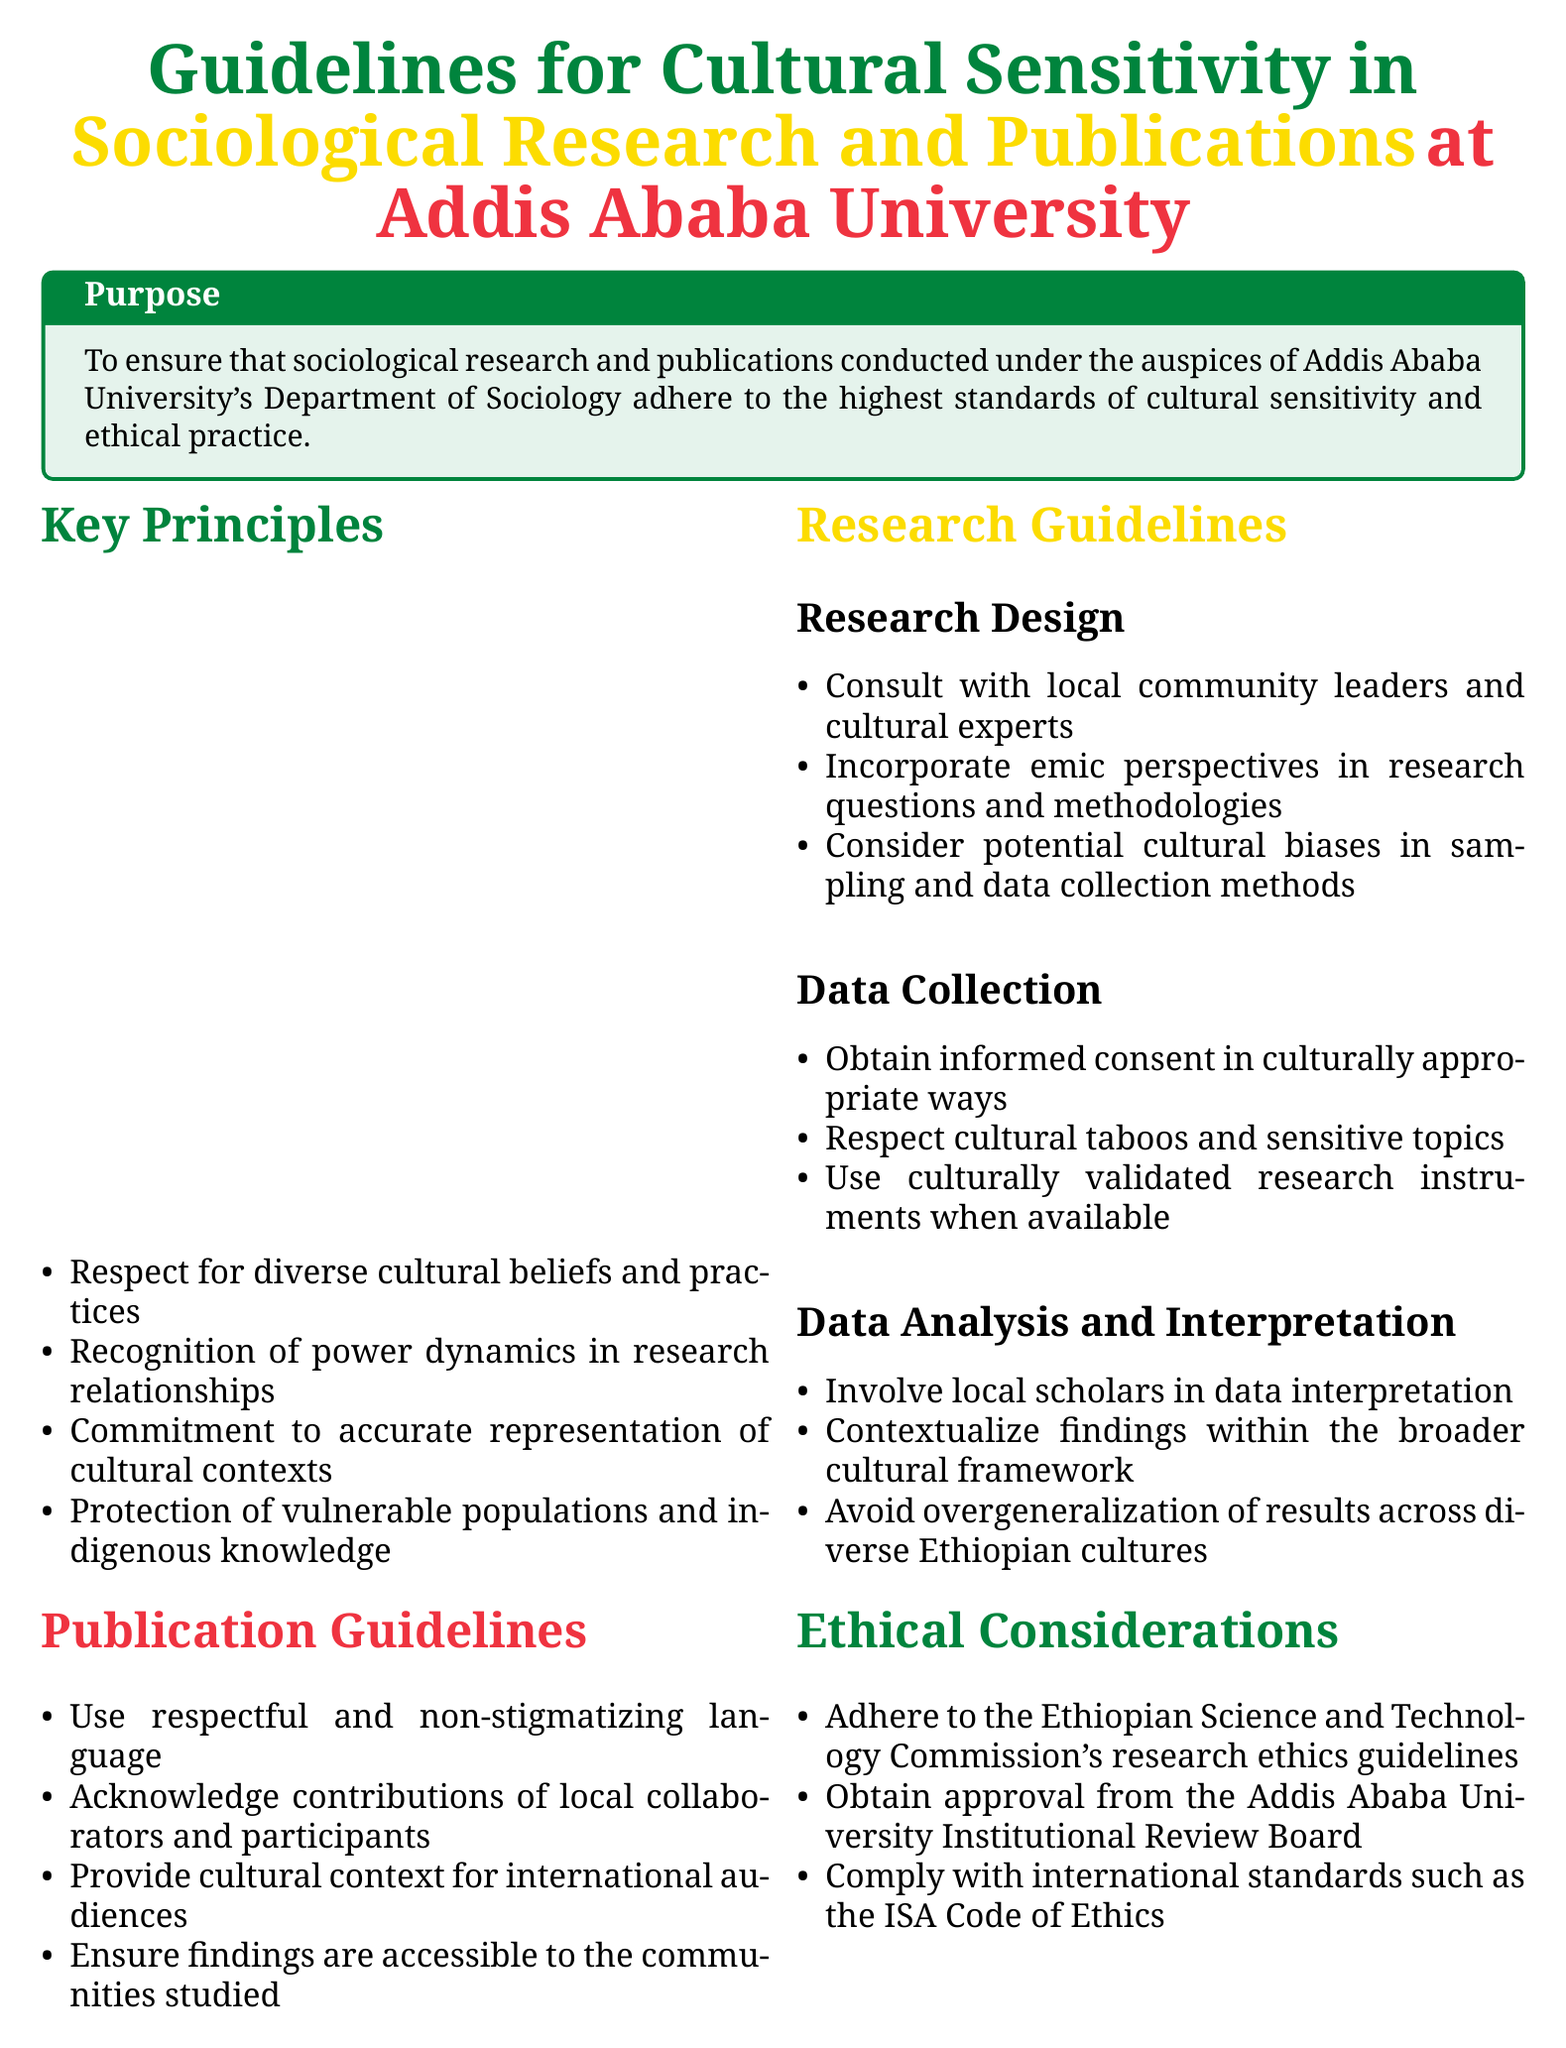What is the purpose of the guidelines? The purpose is to ensure that sociological research and publications conducted under the auspices of Addis Ababa University's Department of Sociology adhere to the highest standards of cultural sensitivity and ethical practice.
Answer: To ensure cultural sensitivity and ethical practice How many key principles are outlined in the document? The key principles are listed in the document's section on Key Principles, which includes four specific items.
Answer: Four What is a requirement for cultural sensitivity training? The document specifies that cultural sensitivity training is mandatory for all researchers and students.
Answer: Mandatory for all researchers and students Who must approve research proposals and publications? The document states that research proposals and publications must be approved by the Addis Ababa University Institutional Review Board.
Answer: Addis Ababa University Institutional Review Board What kind of dynamics should be recognized in research relationships? The document highlights the importance of recognizing power dynamics in research relationships as one of the key principles.
Answer: Power dynamics What type of language should be used in publications? The publication guidelines indicate that researchers should use respectful and non-stigmatizing language.
Answer: Respectful and non-stigmatizing language Which organization must an ethical adherence be aligned with? The guidelines state adherence must be to the Ethiopian Science and Technology Commission's research ethics guidelines.
Answer: Ethiopian Science and Technology Commission What should researchers ensure regarding findings? The publication guidelines indicate that researchers should ensure findings are accessible to the communities studied.
Answer: Accessible to the communities studied Which types of perspectives should be incorporated in research design? The document mentions that emic perspectives should be incorporated in research questions and methodologies.
Answer: Emic perspectives 